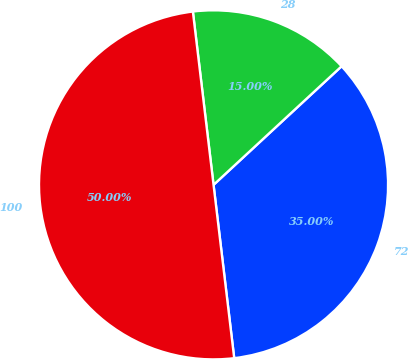Convert chart. <chart><loc_0><loc_0><loc_500><loc_500><pie_chart><fcel>72<fcel>28<fcel>100<nl><fcel>35.0%<fcel>15.0%<fcel>50.0%<nl></chart> 